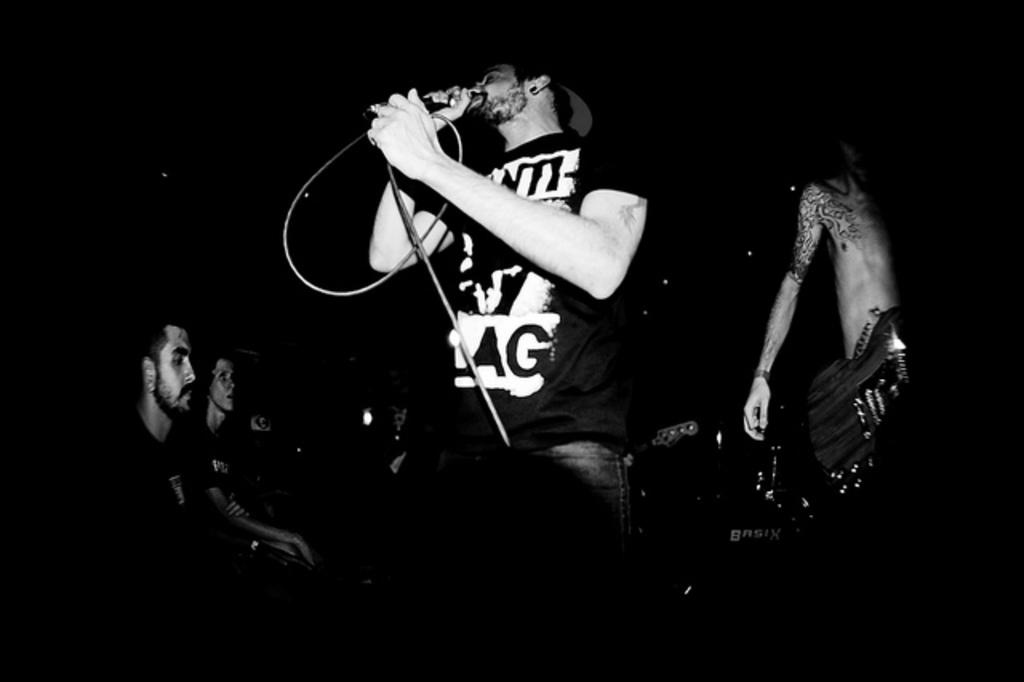What is the man in the image doing? The man in the image is standing and singing. What is the man using to amplify his voice? The man is using a microphone. What are the other people in the image doing? The other people in the image are seated. Is there anyone else standing near the singer? Yes, there is another man standing on the side of the singer. How many waves can be seen crashing on the shore in the image? There are no waves visible in the image; it features a man singing with a microphone and other people seated. 